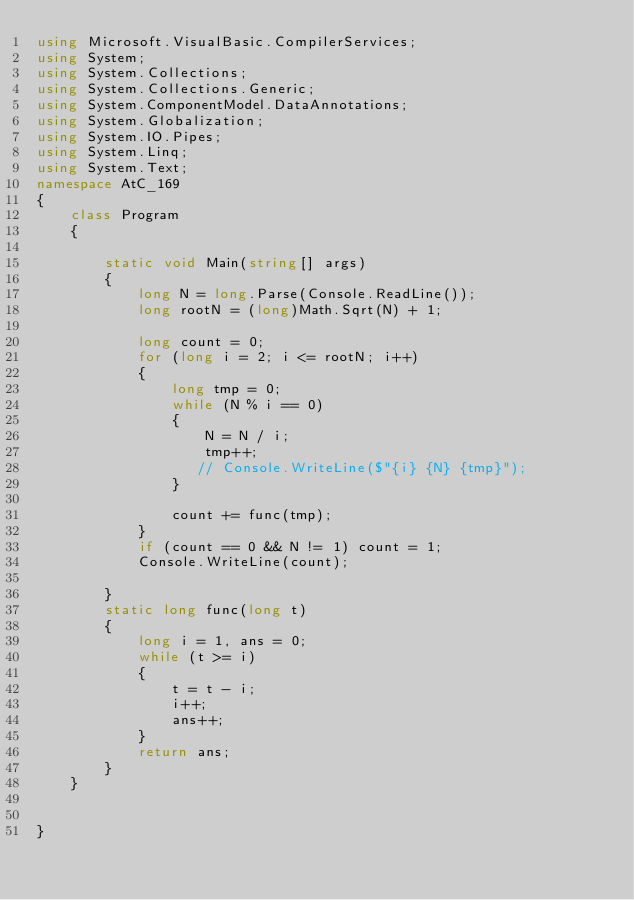<code> <loc_0><loc_0><loc_500><loc_500><_C#_>using Microsoft.VisualBasic.CompilerServices;
using System;
using System.Collections;
using System.Collections.Generic;
using System.ComponentModel.DataAnnotations;
using System.Globalization;
using System.IO.Pipes;
using System.Linq;
using System.Text;
namespace AtC_169
{
    class Program
    {

        static void Main(string[] args)
        {
            long N = long.Parse(Console.ReadLine());
            long rootN = (long)Math.Sqrt(N) + 1;

            long count = 0;
            for (long i = 2; i <= rootN; i++)
            {
                long tmp = 0;
                while (N % i == 0)
                {
                    N = N / i;
                    tmp++;
                   // Console.WriteLine($"{i} {N} {tmp}");
                }
                
                count += func(tmp);
            }
            if (count == 0 && N != 1) count = 1;
            Console.WriteLine(count);

        }
        static long func(long t)
        {
            long i = 1, ans = 0;
            while (t >= i)
            {
                t = t - i;
                i++;
                ans++;
            }
            return ans;
        }
    }

    
}

</code> 